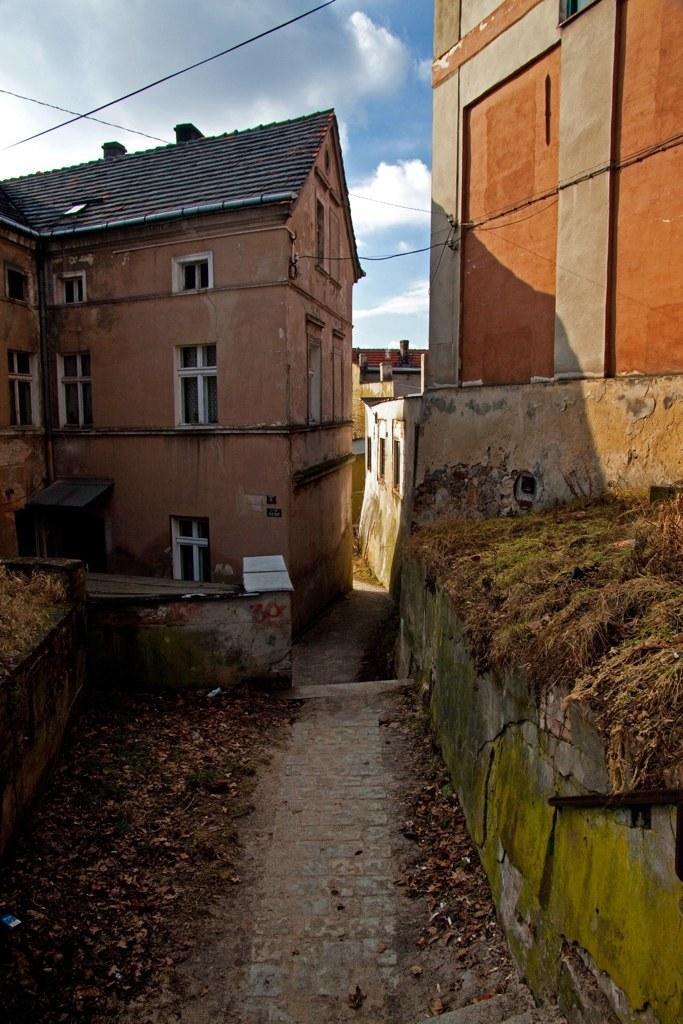How would you summarize this image in a sentence or two? In the image there are some apartments and in front of the apartments there is a path and there are many dry leaves around that path and on the right side there is a wall and there is a lot of dry grass above the wall, in the background there is a sky. 